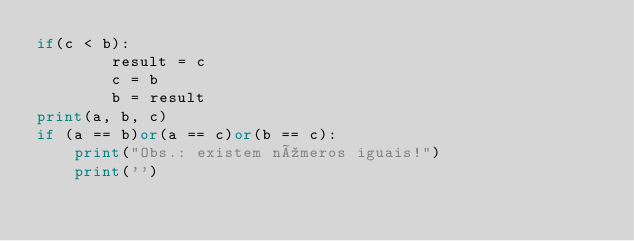<code> <loc_0><loc_0><loc_500><loc_500><_Python_>if(c < b):
        result = c
        c = b
        b = result
print(a, b, c)
if (a == b)or(a == c)or(b == c):
    print("Obs.: existem números iguais!")
    print('')</code> 